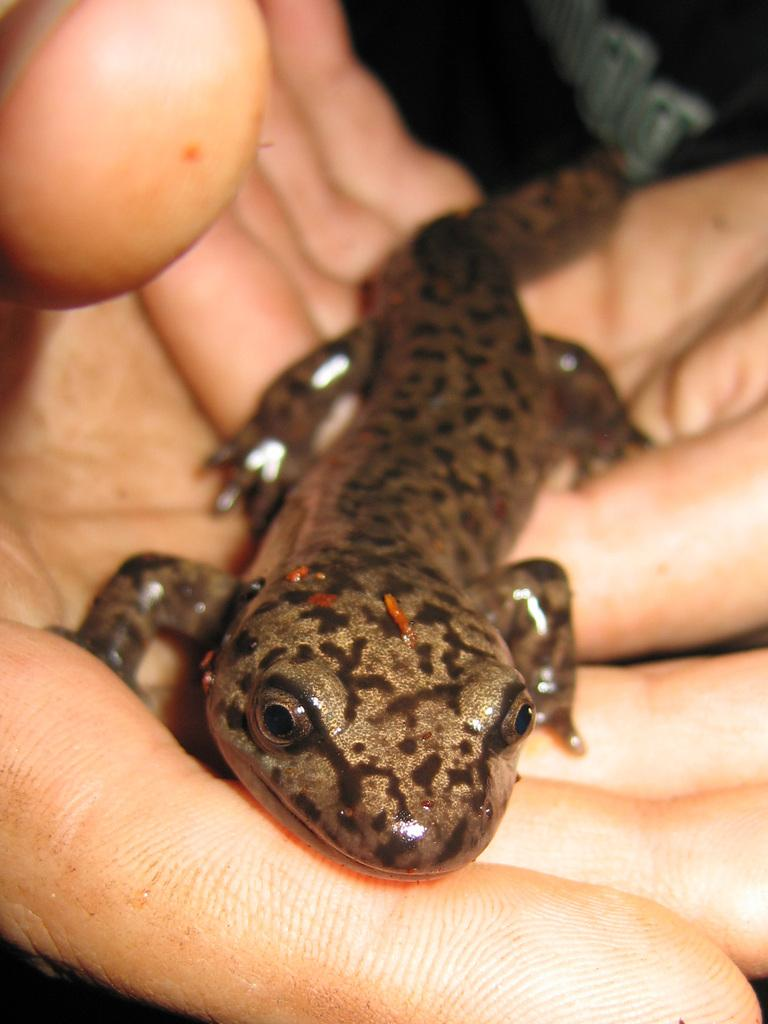What type of animal is in the picture? There is a reptile in the picture. How is the reptile being held or interacted with? The reptile is on the hands of a person. What type of ink is the reptile using to write a letter in the image? There is no ink or letter-writing activity present in the image; it features a reptile on the hands of a person. 